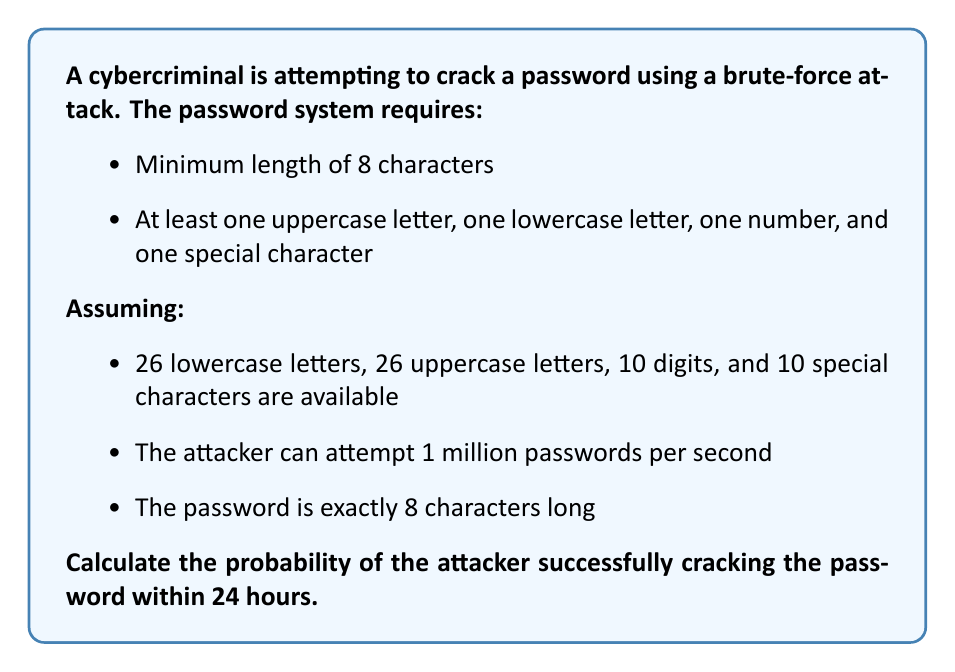What is the answer to this math problem? 1. Calculate the total number of possible passwords:
   $$ N = 72^8 = (26 + 26 + 10 + 10)^8 = 722,204,136,308,736 $$

2. Calculate the number of password attempts in 24 hours:
   $$ A = 1,000,000 \times 60 \times 60 \times 24 = 86,400,000,000 $$

3. The probability of success is the number of attempts divided by the total number of possibilities:
   $$ P(\text{success}) = \frac{A}{N} = \frac{86,400,000,000}{722,204,136,308,736} \approx 0.000119633 $$

4. Convert to percentage:
   $$ P(\text{success}) \approx 0.0119633\% $$
Answer: $0.0119633\%$ 